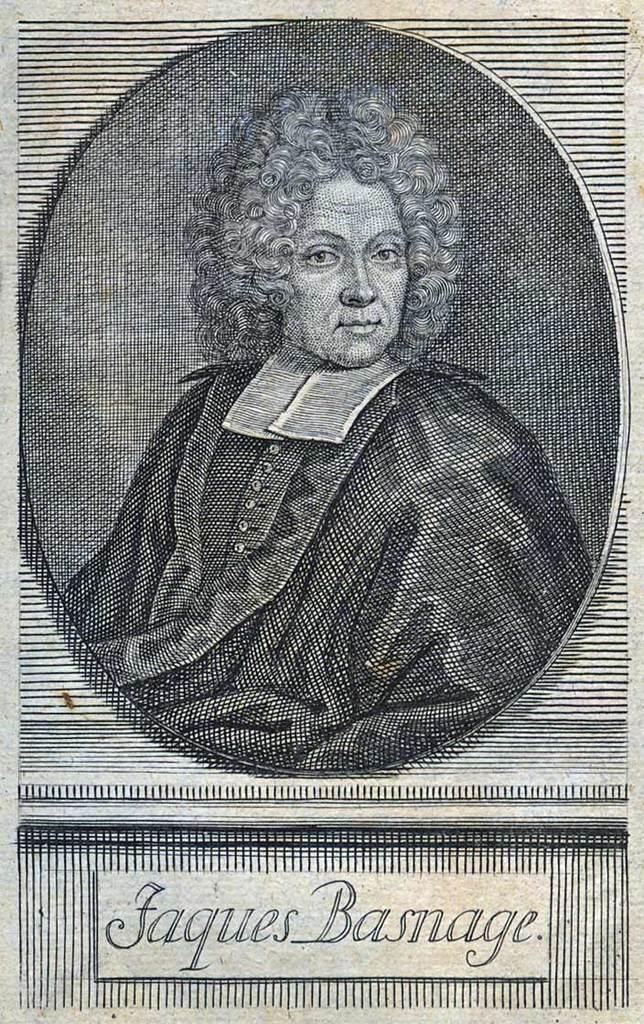In one or two sentences, can you explain what this image depicts? In this picture there is a poster. Here we can see a man who is wearing black dress. On the bottom we can see a person's name. 